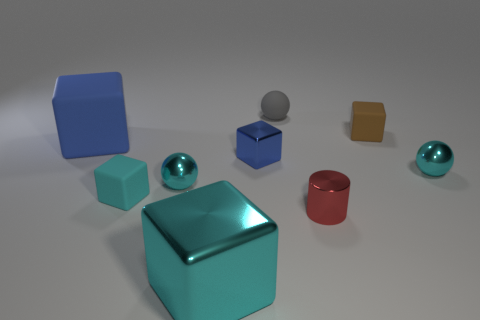Subtract all gray blocks. Subtract all brown spheres. How many blocks are left? 5 Add 1 cyan cylinders. How many objects exist? 10 Subtract all spheres. How many objects are left? 6 Add 9 big blue cubes. How many big blue cubes exist? 10 Subtract 0 green spheres. How many objects are left? 9 Subtract all yellow metallic cylinders. Subtract all small gray things. How many objects are left? 8 Add 1 blue things. How many blue things are left? 3 